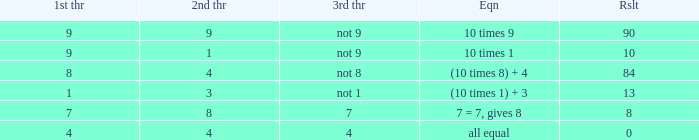If the equation is all equal, what is the 3rd throw? 4.0. 